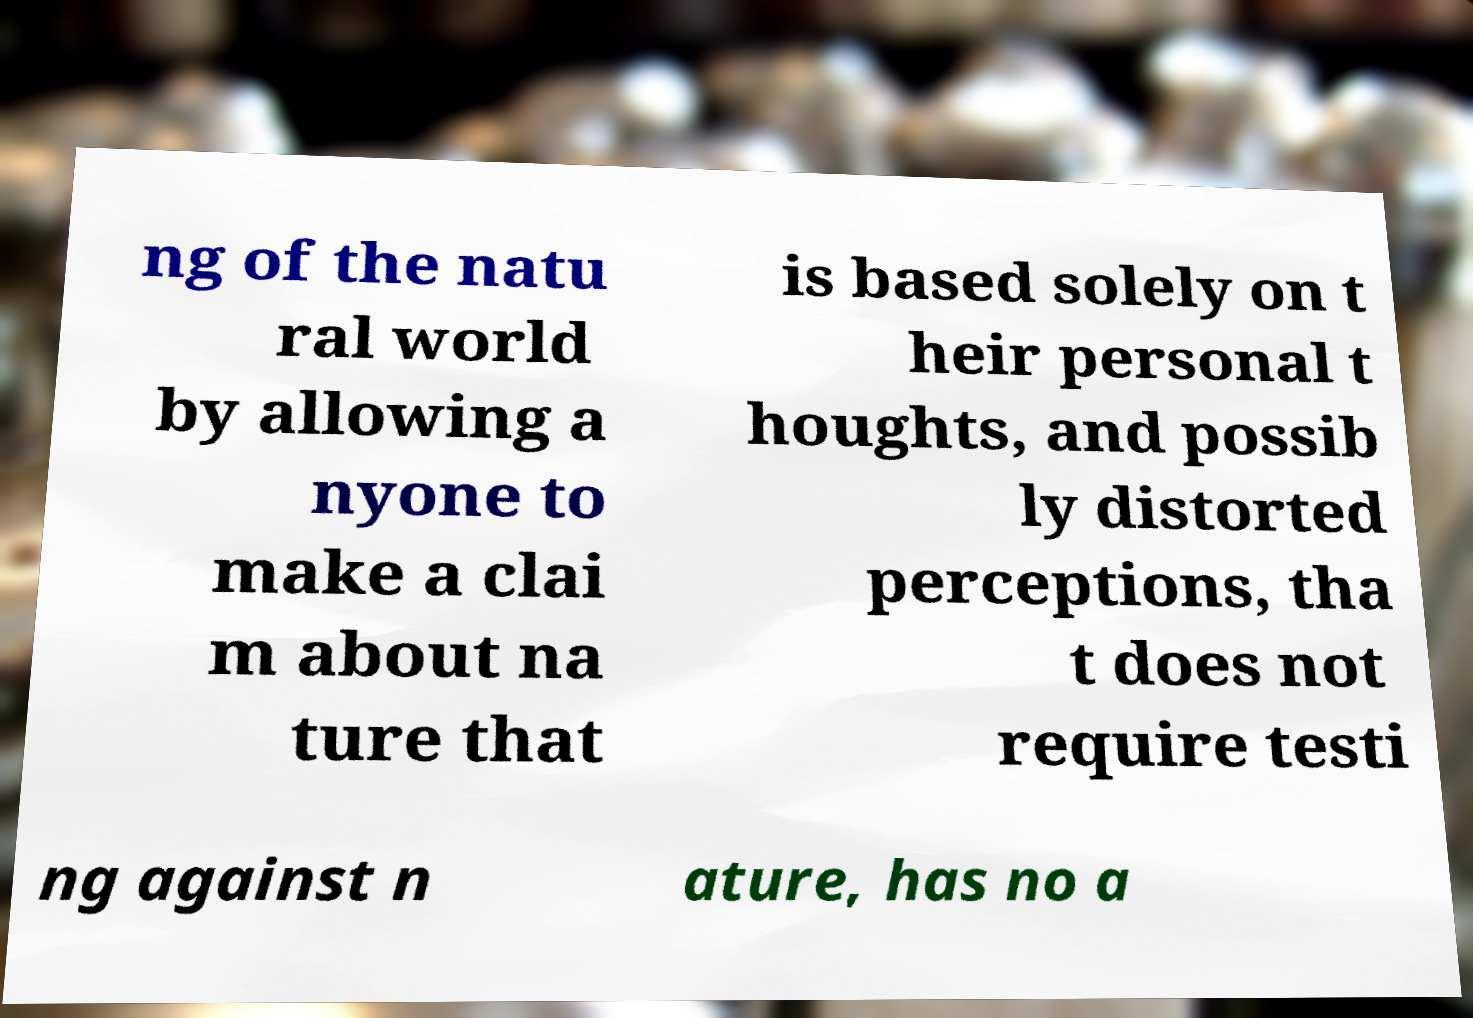Could you extract and type out the text from this image? ng of the natu ral world by allowing a nyone to make a clai m about na ture that is based solely on t heir personal t houghts, and possib ly distorted perceptions, tha t does not require testi ng against n ature, has no a 